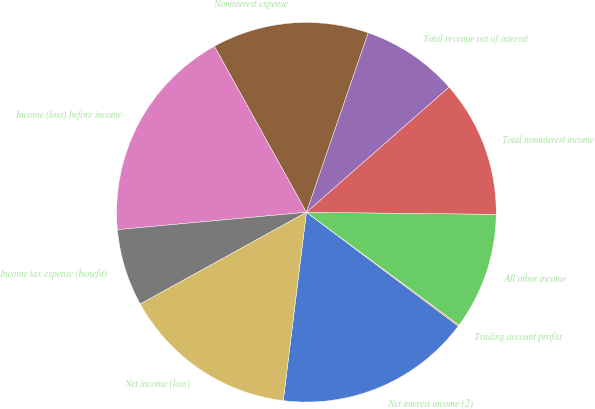Convert chart. <chart><loc_0><loc_0><loc_500><loc_500><pie_chart><fcel>Net interest income (2)<fcel>Trading account profits<fcel>All other income<fcel>Total noninterest income<fcel>Total revenue net of interest<fcel>Noninterest expense<fcel>Income (loss) before income<fcel>Income tax expense (benefit)<fcel>Net income (loss)<nl><fcel>16.71%<fcel>0.11%<fcel>9.95%<fcel>11.64%<fcel>8.26%<fcel>13.33%<fcel>18.4%<fcel>6.57%<fcel>15.02%<nl></chart> 